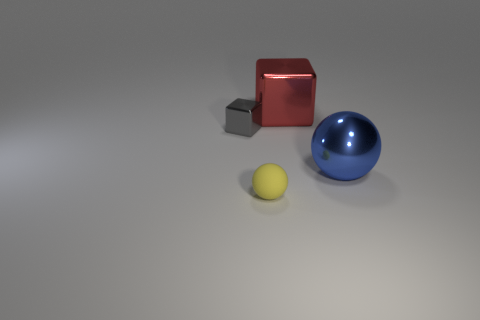Add 2 large gray metal balls. How many objects exist? 6 Subtract all brown blocks. Subtract all purple spheres. How many blocks are left? 2 Add 3 gray cubes. How many gray cubes are left? 4 Add 2 small red cubes. How many small red cubes exist? 2 Subtract 0 purple cubes. How many objects are left? 4 Subtract all blue objects. Subtract all blue metal objects. How many objects are left? 2 